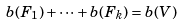Convert formula to latex. <formula><loc_0><loc_0><loc_500><loc_500>b ( F _ { 1 } ) + \dots + b ( F _ { k } ) = b ( V )</formula> 